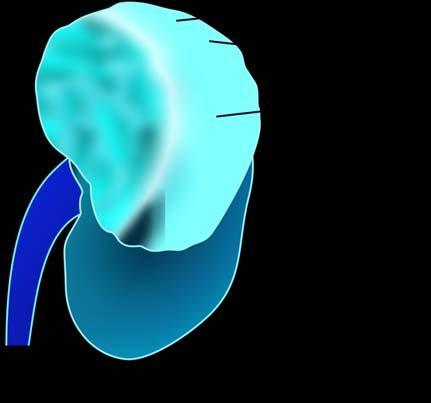does sectioned surface show irregular, circumscribed, yellowish mass with areas of haemorrhages and necrosis?
Answer the question using a single word or phrase. Yes 